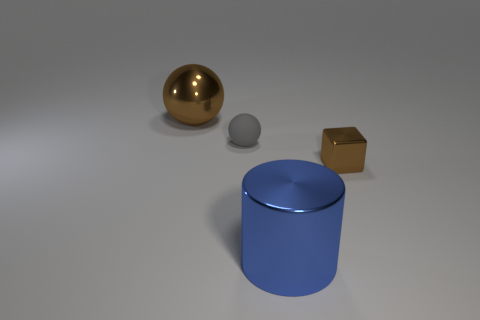What is the shape of the thing that is right of the small sphere and behind the large cylinder? cube 